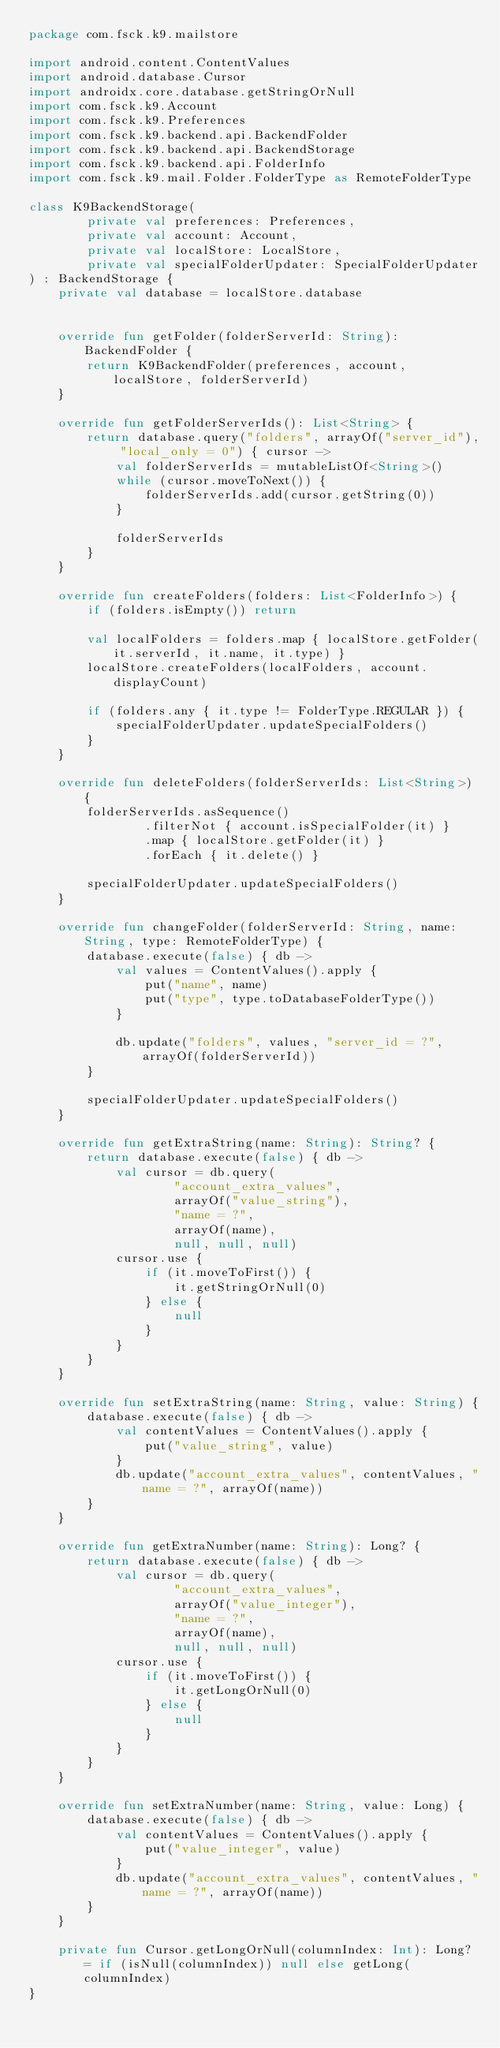Convert code to text. <code><loc_0><loc_0><loc_500><loc_500><_Kotlin_>package com.fsck.k9.mailstore

import android.content.ContentValues
import android.database.Cursor
import androidx.core.database.getStringOrNull
import com.fsck.k9.Account
import com.fsck.k9.Preferences
import com.fsck.k9.backend.api.BackendFolder
import com.fsck.k9.backend.api.BackendStorage
import com.fsck.k9.backend.api.FolderInfo
import com.fsck.k9.mail.Folder.FolderType as RemoteFolderType

class K9BackendStorage(
        private val preferences: Preferences,
        private val account: Account,
        private val localStore: LocalStore,
        private val specialFolderUpdater: SpecialFolderUpdater
) : BackendStorage {
    private val database = localStore.database


    override fun getFolder(folderServerId: String): BackendFolder {
        return K9BackendFolder(preferences, account, localStore, folderServerId)
    }

    override fun getFolderServerIds(): List<String> {
        return database.query("folders", arrayOf("server_id"), "local_only = 0") { cursor ->
            val folderServerIds = mutableListOf<String>()
            while (cursor.moveToNext()) {
                folderServerIds.add(cursor.getString(0))
            }

            folderServerIds
        }
    }

    override fun createFolders(folders: List<FolderInfo>) {
        if (folders.isEmpty()) return

        val localFolders = folders.map { localStore.getFolder(it.serverId, it.name, it.type) }
        localStore.createFolders(localFolders, account.displayCount)

        if (folders.any { it.type != FolderType.REGULAR }) {
            specialFolderUpdater.updateSpecialFolders()
        }
    }

    override fun deleteFolders(folderServerIds: List<String>) {
        folderServerIds.asSequence()
                .filterNot { account.isSpecialFolder(it) }
                .map { localStore.getFolder(it) }
                .forEach { it.delete() }

        specialFolderUpdater.updateSpecialFolders()
    }

    override fun changeFolder(folderServerId: String, name: String, type: RemoteFolderType) {
        database.execute(false) { db ->
            val values = ContentValues().apply {
                put("name", name)
                put("type", type.toDatabaseFolderType())
            }

            db.update("folders", values, "server_id = ?", arrayOf(folderServerId))
        }

        specialFolderUpdater.updateSpecialFolders()
    }

    override fun getExtraString(name: String): String? {
        return database.execute(false) { db ->
            val cursor = db.query(
                    "account_extra_values",
                    arrayOf("value_string"),
                    "name = ?",
                    arrayOf(name),
                    null, null, null)
            cursor.use {
                if (it.moveToFirst()) {
                    it.getStringOrNull(0)
                } else {
                    null
                }
            }
        }
    }

    override fun setExtraString(name: String, value: String) {
        database.execute(false) { db ->
            val contentValues = ContentValues().apply {
                put("value_string", value)
            }
            db.update("account_extra_values", contentValues, "name = ?", arrayOf(name))
        }
    }

    override fun getExtraNumber(name: String): Long? {
        return database.execute(false) { db ->
            val cursor = db.query(
                    "account_extra_values",
                    arrayOf("value_integer"),
                    "name = ?",
                    arrayOf(name),
                    null, null, null)
            cursor.use {
                if (it.moveToFirst()) {
                    it.getLongOrNull(0)
                } else {
                    null
                }
            }
        }
    }

    override fun setExtraNumber(name: String, value: Long) {
        database.execute(false) { db ->
            val contentValues = ContentValues().apply {
                put("value_integer", value)
            }
            db.update("account_extra_values", contentValues, "name = ?", arrayOf(name))
        }
    }

    private fun Cursor.getLongOrNull(columnIndex: Int): Long? = if (isNull(columnIndex)) null else getLong(columnIndex)
}
</code> 